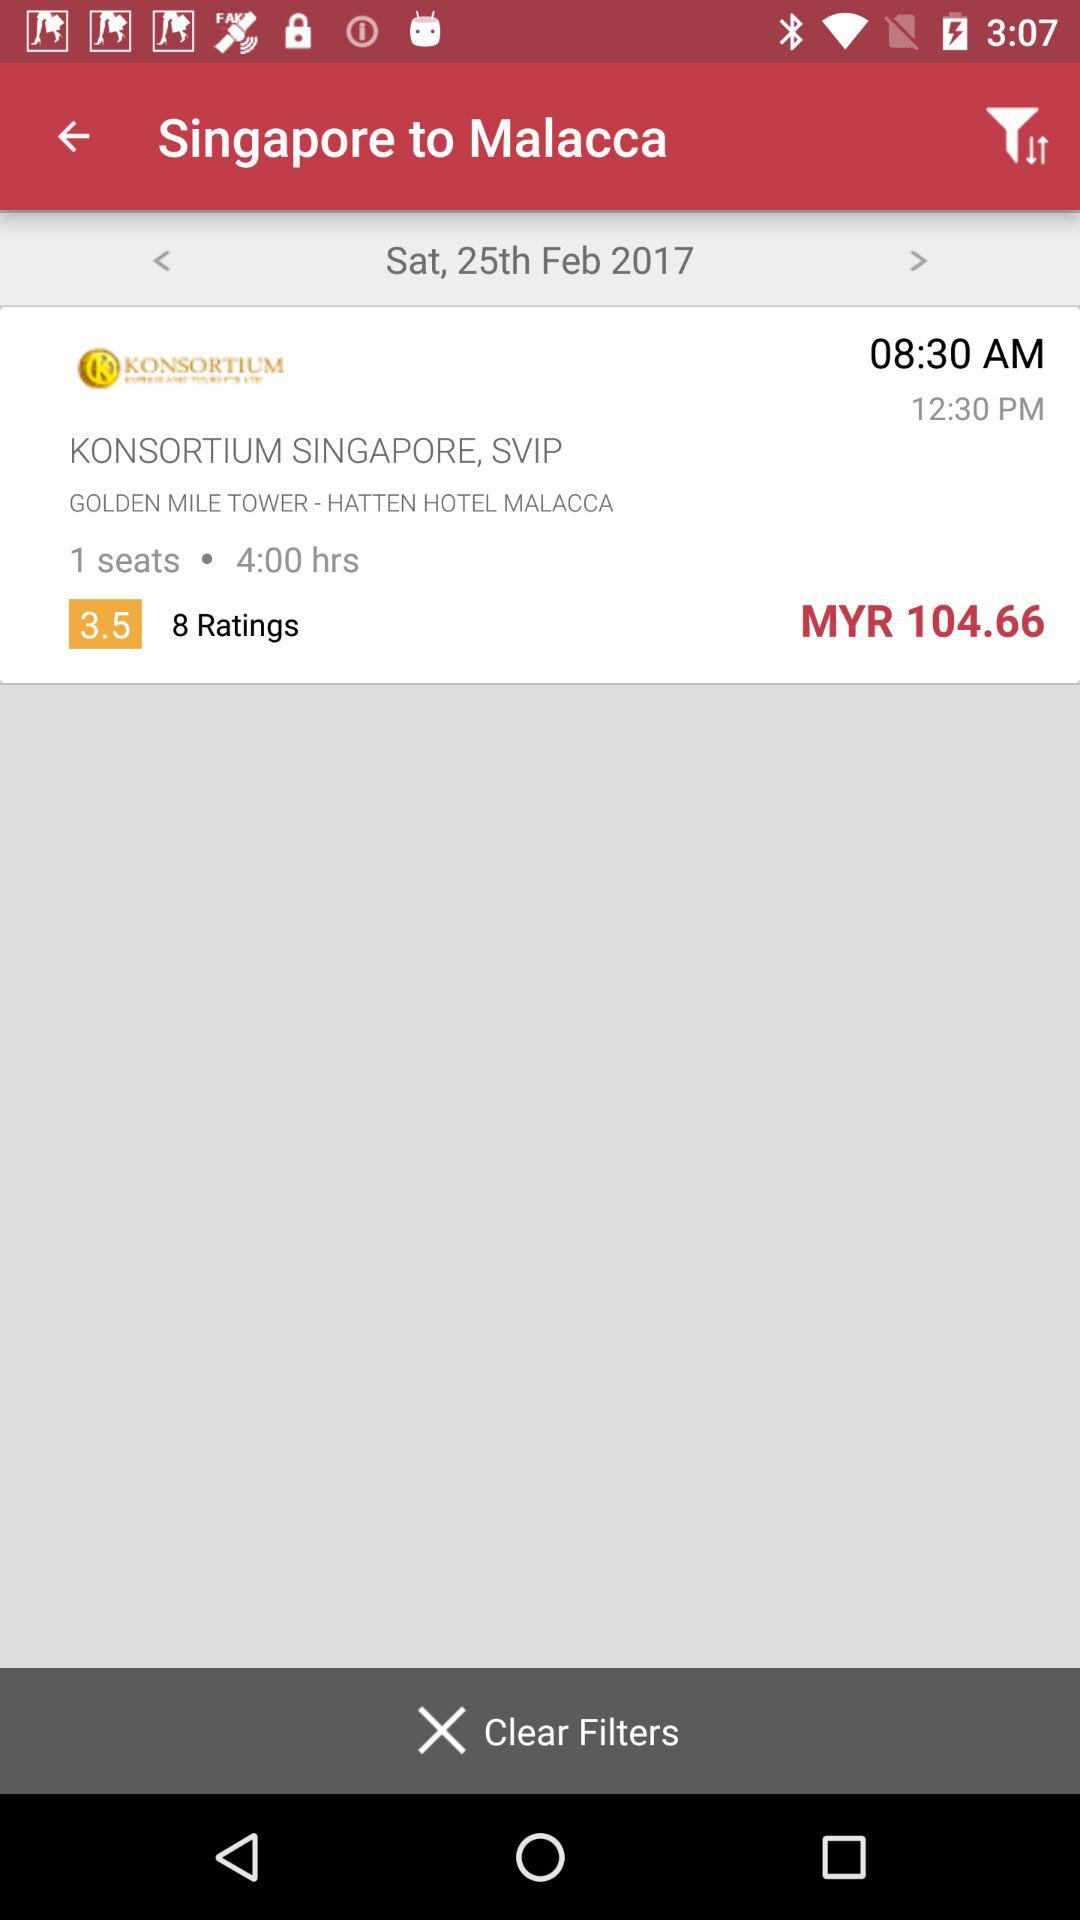How many seats are there? There is 1 seat. 